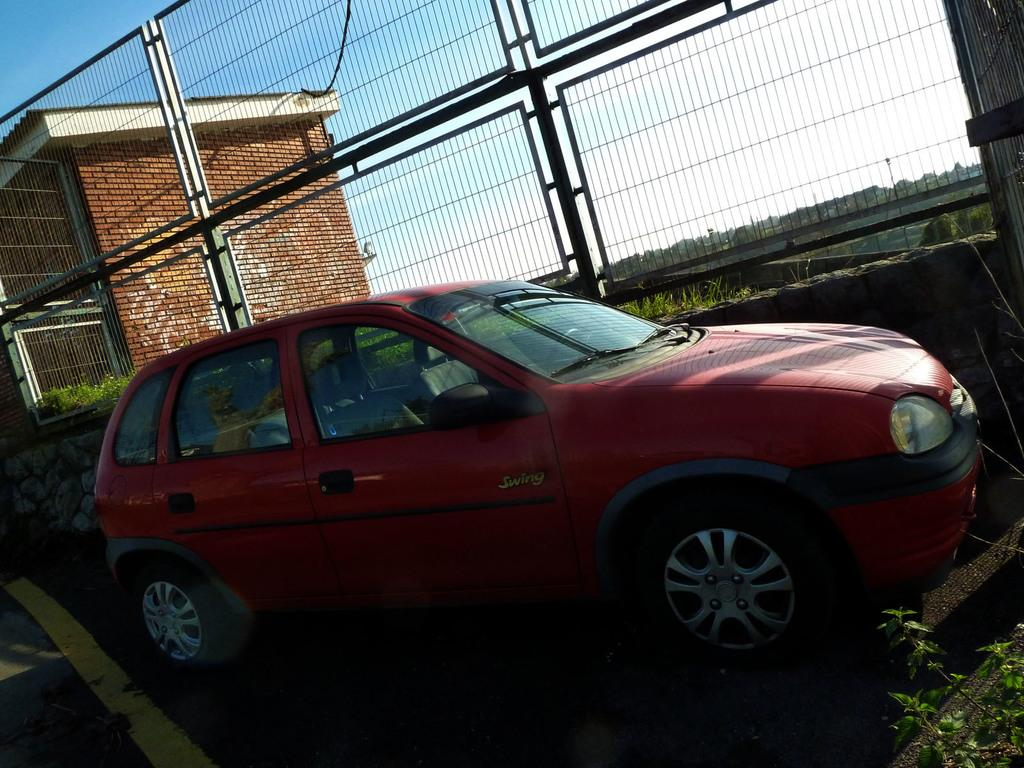What type of vehicle is in the image? There is a red car in the image. Where is the car located? The car is parked on the road. What is in front of the car? There is a wall with a metal fence gate in front of the car. What can be seen in the background of the image? There is a house and a blue sky in the background of the image. What type of pen is the car using to write in the image? There is no pen present in the image, and the car is not writing anything. What kind of soup is being served in the car in the image? There is no soup present in the image, and the car is not serving any food. 